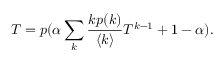<formula> <loc_0><loc_0><loc_500><loc_500>T = p ( \alpha \sum _ { k } \frac { k p ( k ) } { \langle k \rangle } T ^ { k - 1 } + 1 - \alpha ) .</formula> 